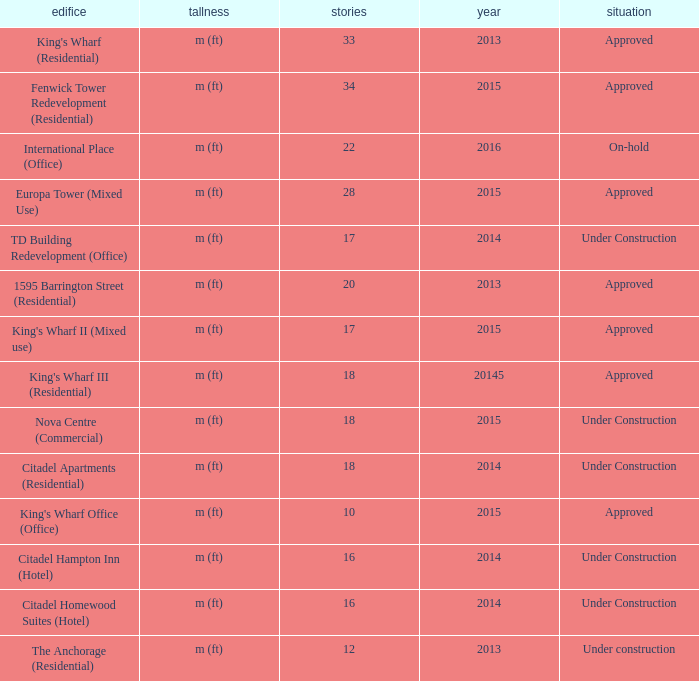What is the status of the building for 2014 with 33 floors? Approved. 